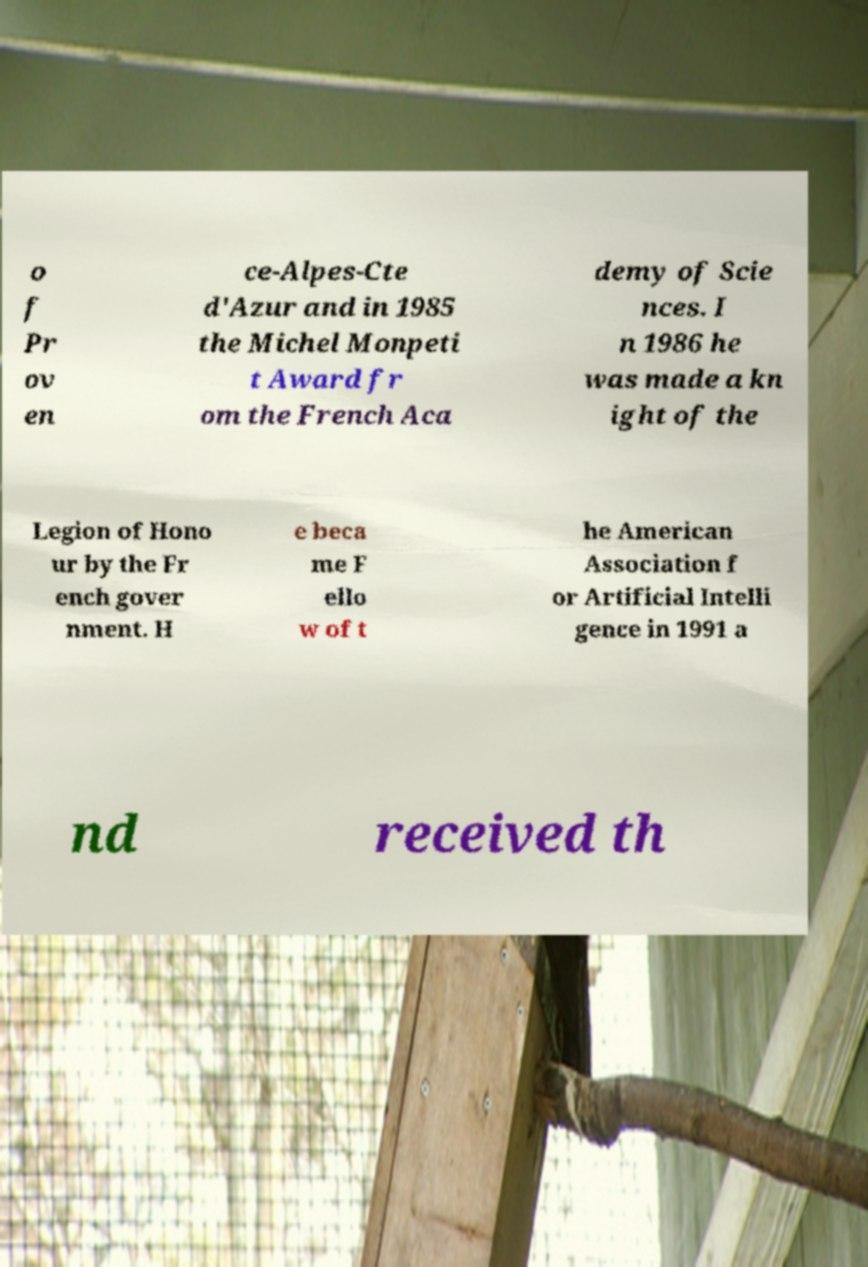There's text embedded in this image that I need extracted. Can you transcribe it verbatim? o f Pr ov en ce-Alpes-Cte d'Azur and in 1985 the Michel Monpeti t Award fr om the French Aca demy of Scie nces. I n 1986 he was made a kn ight of the Legion of Hono ur by the Fr ench gover nment. H e beca me F ello w of t he American Association f or Artificial Intelli gence in 1991 a nd received th 